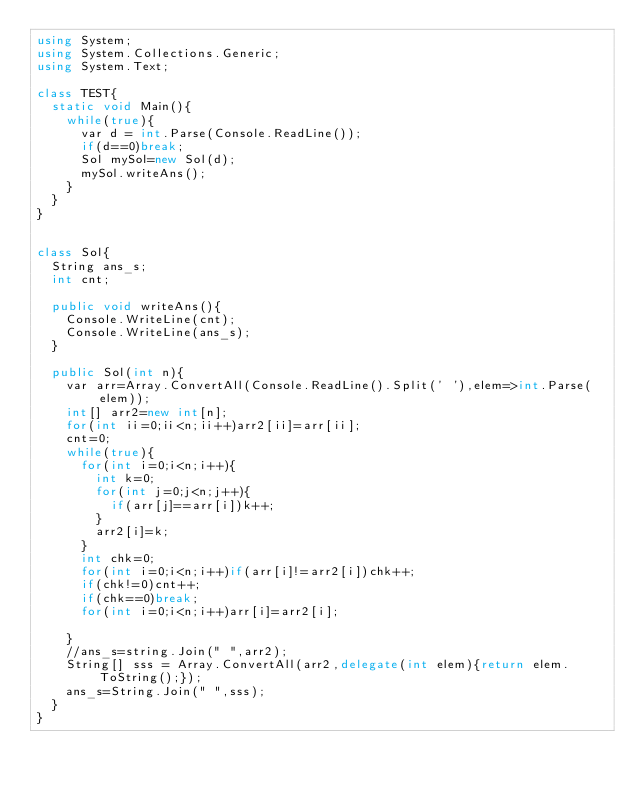Convert code to text. <code><loc_0><loc_0><loc_500><loc_500><_C#_>using System;
using System.Collections.Generic;
using System.Text;

class TEST{
	static void Main(){
		while(true){
			var d = int.Parse(Console.ReadLine());
			if(d==0)break;
			Sol mySol=new Sol(d);
			mySol.writeAns();
		}
	}
}


class Sol{
	String ans_s;
	int cnt;
	
	public void writeAns(){
		Console.WriteLine(cnt);
		Console.WriteLine(ans_s);
	}
	
	public Sol(int n){
		var arr=Array.ConvertAll(Console.ReadLine().Split(' '),elem=>int.Parse(elem));
		int[] arr2=new int[n];
		for(int ii=0;ii<n;ii++)arr2[ii]=arr[ii];
		cnt=0;
		while(true){
			for(int i=0;i<n;i++){
				int k=0;
				for(int j=0;j<n;j++){
					if(arr[j]==arr[i])k++;
				}
				arr2[i]=k;
			}
			int chk=0;
			for(int i=0;i<n;i++)if(arr[i]!=arr2[i])chk++;
			if(chk!=0)cnt++;
			if(chk==0)break;
			for(int i=0;i<n;i++)arr[i]=arr2[i];

		}
		//ans_s=string.Join(" ",arr2);
		String[] sss = Array.ConvertAll(arr2,delegate(int elem){return elem.ToString();});
		ans_s=String.Join(" ",sss);
	}
}	</code> 